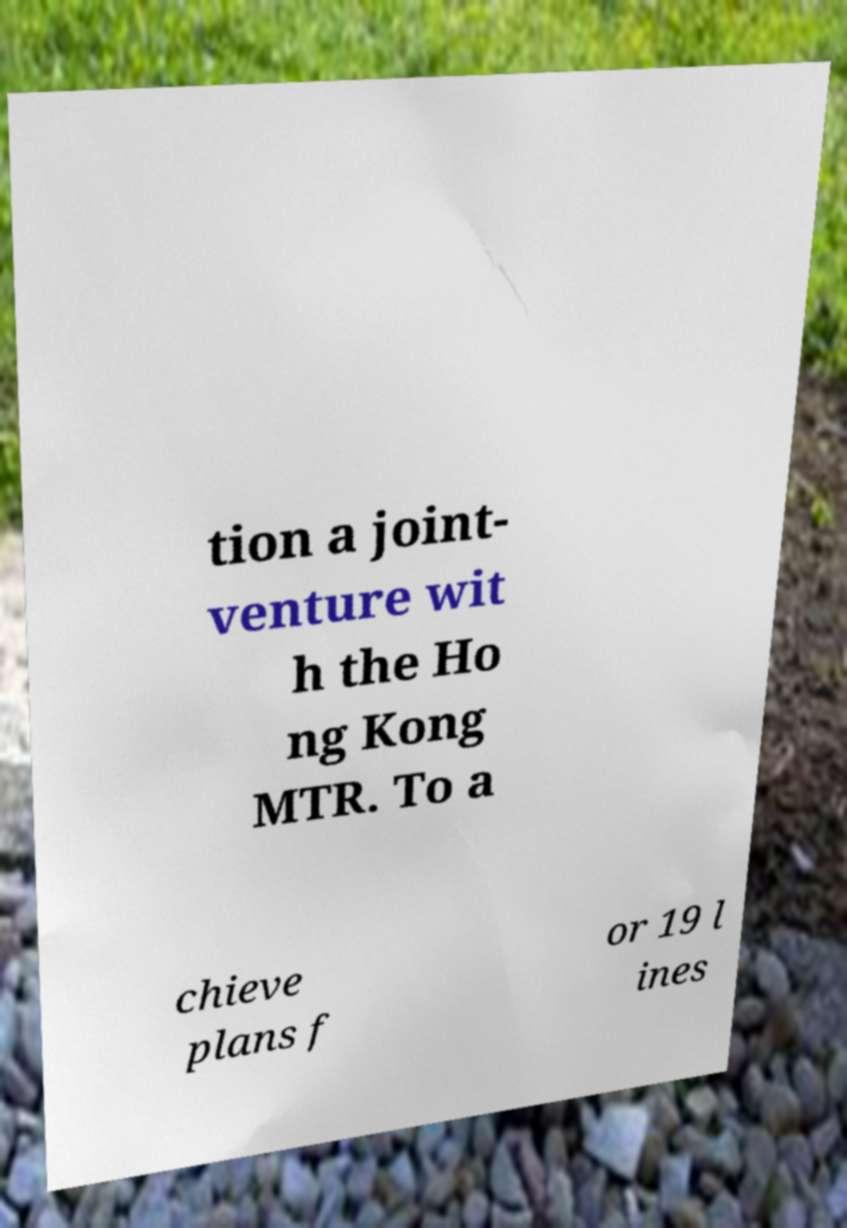Could you extract and type out the text from this image? tion a joint- venture wit h the Ho ng Kong MTR. To a chieve plans f or 19 l ines 